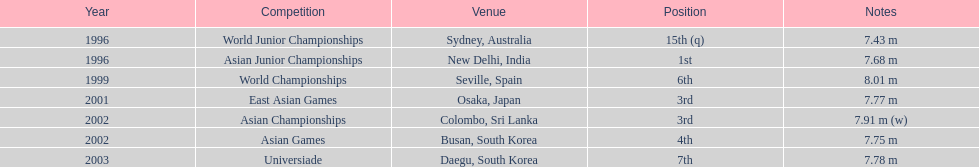I'm looking to parse the entire table for insights. Could you assist me with that? {'header': ['Year', 'Competition', 'Venue', 'Position', 'Notes'], 'rows': [['1996', 'World Junior Championships', 'Sydney, Australia', '15th (q)', '7.43 m'], ['1996', 'Asian Junior Championships', 'New Delhi, India', '1st', '7.68 m'], ['1999', 'World Championships', 'Seville, Spain', '6th', '8.01 m'], ['2001', 'East Asian Games', 'Osaka, Japan', '3rd', '7.77 m'], ['2002', 'Asian Championships', 'Colombo, Sri Lanka', '3rd', '7.91 m (w)'], ['2002', 'Asian Games', 'Busan, South Korea', '4th', '7.75 m'], ['2003', 'Universiade', 'Daegu, South Korea', '7th', '7.78 m']]} 70 m? 5. 